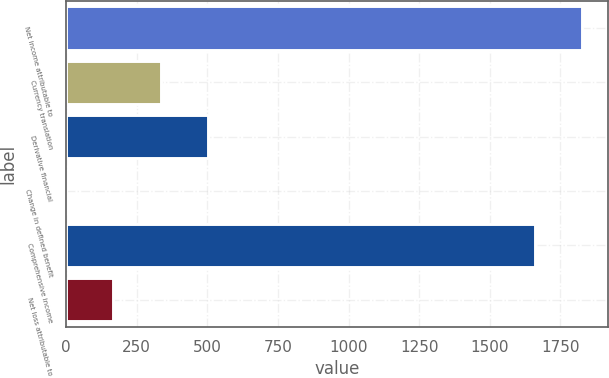Convert chart to OTSL. <chart><loc_0><loc_0><loc_500><loc_500><bar_chart><fcel>Net income attributable to<fcel>Currency translation<fcel>Derivative financial<fcel>Change in defined benefit<fcel>Comprehensive income<fcel>Net loss attributable to<nl><fcel>1826.7<fcel>334.4<fcel>501.1<fcel>1<fcel>1660<fcel>167.7<nl></chart> 